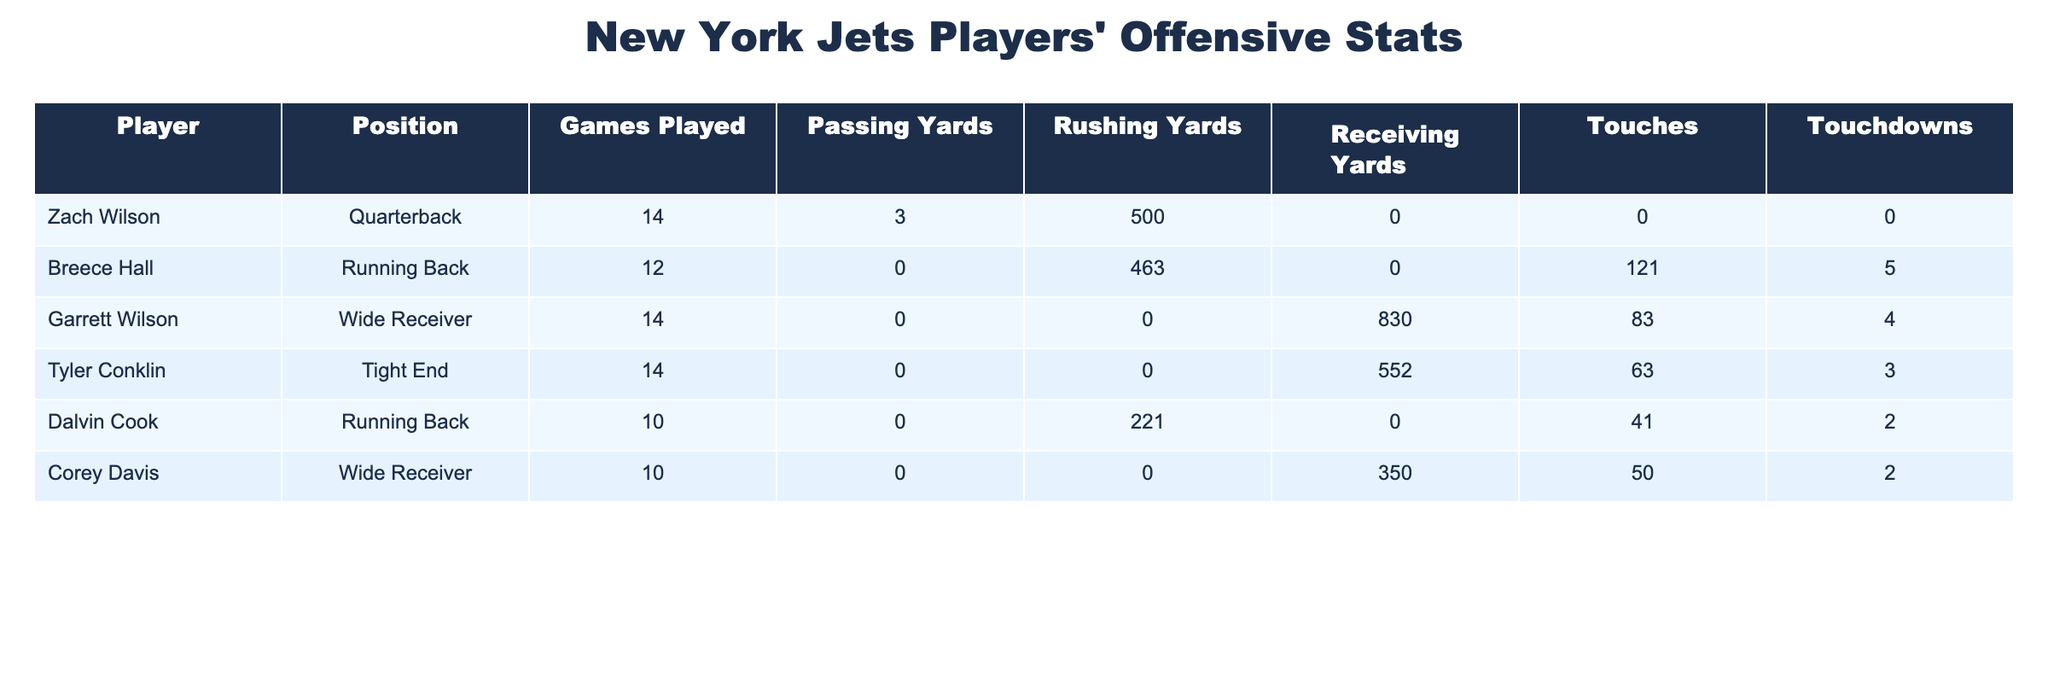What is the total number of touchdowns scored by all players listed? To find the total number of touchdowns, I will sum the touchdowns scored by each player. The touchdowns are: Breece Hall (5), Garrett Wilson (4), Tyler Conklin (3), Dalvin Cook (2), and Corey Davis (2). Adding these together gives 5 + 4 + 3 + 2 + 2 = 16.
Answer: 16 Which player has the highest rushing yards? I will look through the Rushing Yards column to identify the player with the maximum value. Breece Hall has 463 rushing yards, which is more than the others (Zach Wilson: 500, Dalvin Cook: 221, and the others have 0). Therefore, Breece Hall has the highest rushing yards.
Answer: Breece Hall Did Zach Wilson score any touchdowns? I will check the Touchdowns column for Zach Wilson. The value is 0, indicating he did not score any touchdowns.
Answer: No What is the average passing yards for all players? To calculate the average, I will first sum the passing yards: Zach Wilson (3) + Breece Hall (0) + Garrett Wilson (0) + Tyler Conklin (0) + Dalvin Cook (0) + Corey Davis (0) = 3. There are 6 players, so the average is 3 / 6 = 0.5.
Answer: 0.5 How many players have receiving yards greater than 500? I will compare the Receiving Yards values. Garrett Wilson has 830, and Tyler Conklin has 552, so there are 2 players with receiving yards greater than 500.
Answer: 2 What is the total number of touches by running backs? I will sum the Touches for the running backs: Breece Hall (121) and Dalvin Cook (41). Adding these values gives 121 + 41 = 162 touches.
Answer: 162 Which player played the most games? From the Games Played column, I will look for the maximum value. Zach Wilson, Breece Hall, Garrett Wilson, Tyler Conklin all played 14 games, which is the highest compared to Dalvin Cook (10) and Corey Davis (10).
Answer: 14 Does Corey Davis have more receiving yards than Tyler Conklin? I will compare the Receiving Yards for both players. Corey Davis has 350, while Tyler Conklin has 552. Since 350 is less than 552, Corey Davis does not have more receiving yards.
Answer: No 